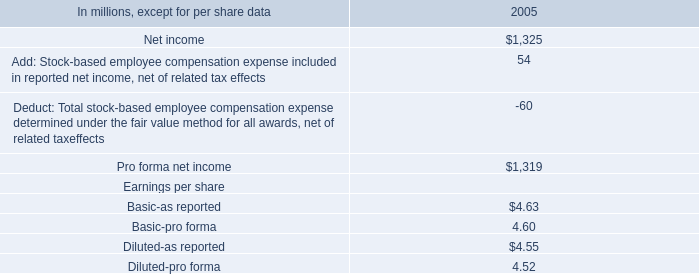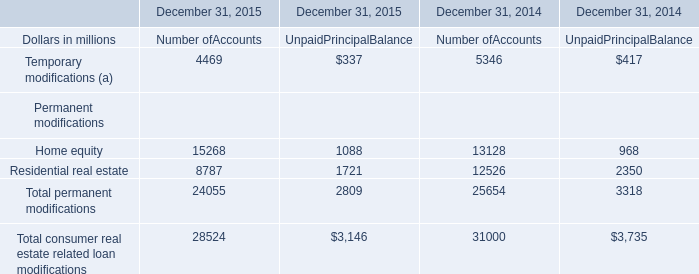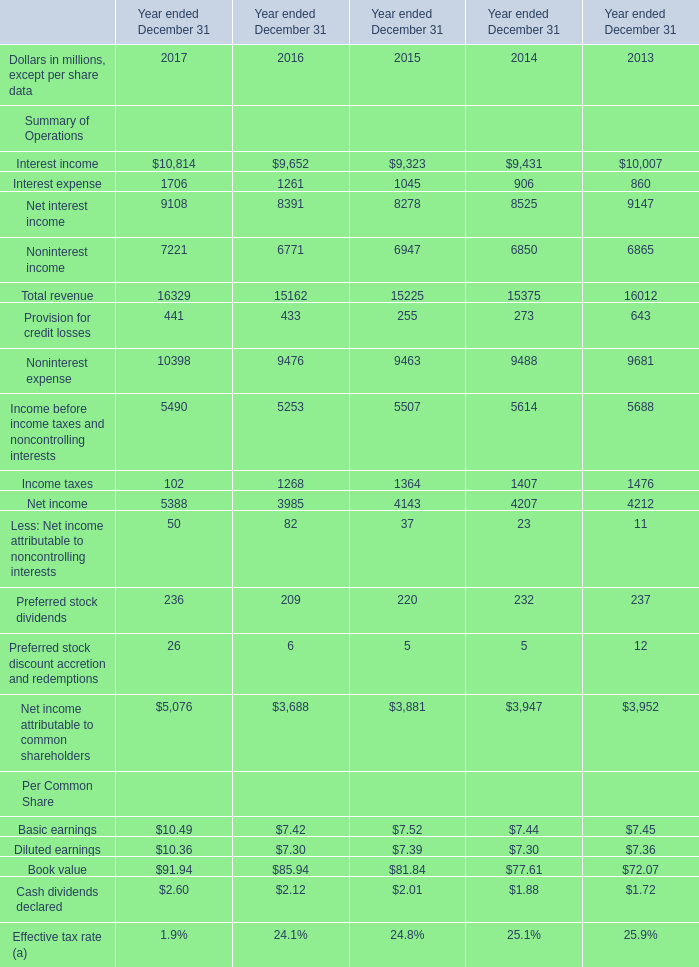what's the total amount of Interest income of Year ended December 31 2016, and Pro forma net income of 2005 ? 
Computations: (9652.0 + 1319.0)
Answer: 10971.0. 